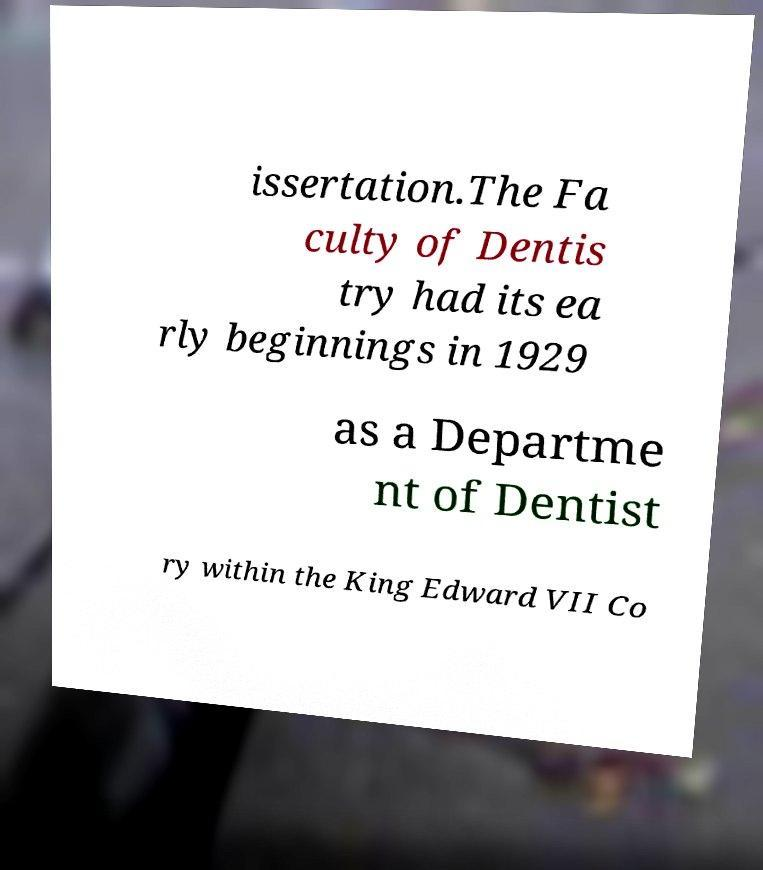Could you assist in decoding the text presented in this image and type it out clearly? issertation.The Fa culty of Dentis try had its ea rly beginnings in 1929 as a Departme nt of Dentist ry within the King Edward VII Co 